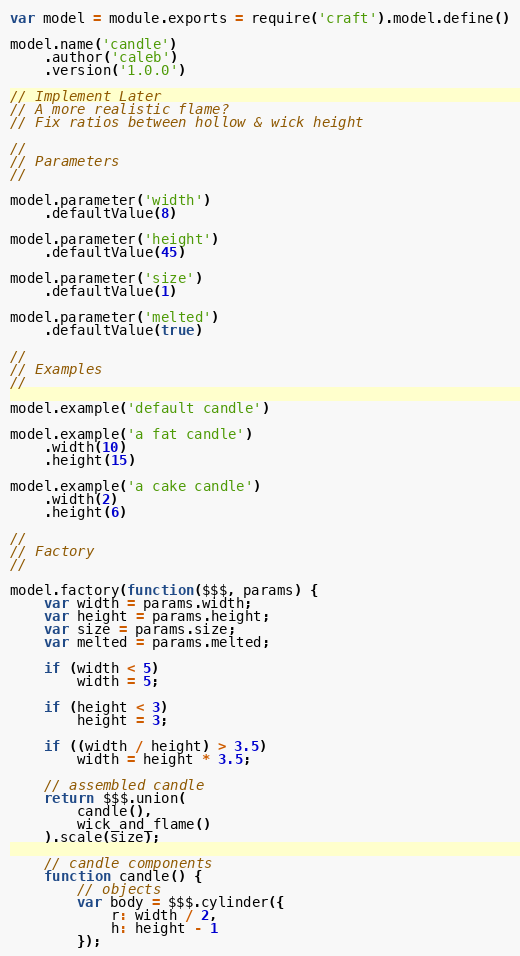<code> <loc_0><loc_0><loc_500><loc_500><_JavaScript_>var model = module.exports = require('craft').model.define()

model.name('candle')
	.author('caleb')
	.version('1.0.0')

// Implement Later
// A more realistic flame?
// Fix ratios between hollow & wick height

//
// Parameters
//

model.parameter('width')
	.defaultValue(8)

model.parameter('height')
	.defaultValue(45)

model.parameter('size')
	.defaultValue(1)

model.parameter('melted')
	.defaultValue(true)

//
// Examples
//

model.example('default candle')

model.example('a fat candle')
	.width(10)
	.height(15)

model.example('a cake candle')
	.width(2)
	.height(6)

//
// Factory
//

model.factory(function($$$, params) {
	var width = params.width;
	var height = params.height;
	var size = params.size;
	var melted = params.melted;

	if (width < 5)
		width = 5;

	if (height < 3)
		height = 3;

	if ((width / height) > 3.5)
		width = height * 3.5;

	// assembled candle
	return $$$.union(
		candle(),
		wick_and_flame()
	).scale(size);

	// candle components
	function candle() {
	    // objects
	    var body = $$$.cylinder({
	    	r: width / 2, 
	    	h: height - 1
	    });
</code> 